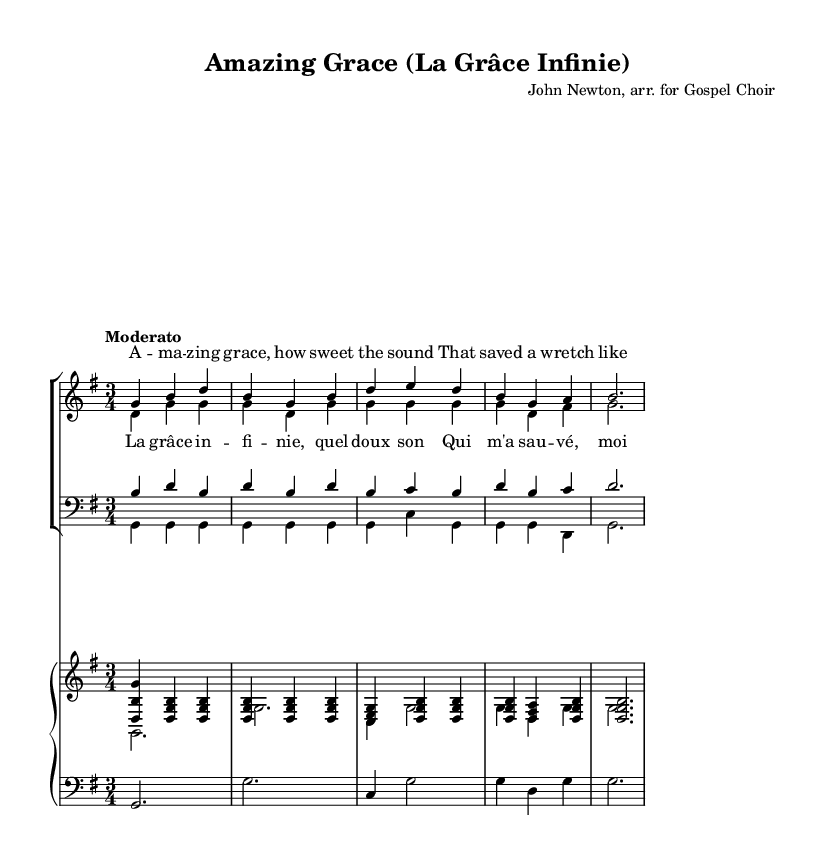What is the key signature of this music? The key signature is G major, which has one sharp (F#). You can determine the key signature by looking at the number of sharps or flats at the beginning of the staff. In this case, there is one sharp present.
Answer: G major What is the time signature of this piece? The time signature is 3/4, which indicates that there are three beats in each measure and the quarter note gets one beat. This can be seen at the beginning of the staff where the time signature is notated.
Answer: 3/4 What is the tempo marking for this arrangement? The tempo marking is "Moderato," indicating a moderate pace for the performance. This is usually written above the staff and provides guidance on the speed at which the piece should be played.
Answer: Moderato How many verses are included in the lyrics for this hymn? There is one verse included in the lyrics section of the sheet music. Although it is typical for hymns to have multiple verses, the provided sheet music shows only a single verse written underneath the soprano and alto parts.
Answer: One What is the primary emotion conveyed in the lyrics of this hymn? The primary emotion conveyed in the lyrics is grace, suggesting feelings of redemption and salvation. This can be inferred from the title and the lyrics that emphasize the sweetness and saving power of grace, which are common themes in Gospel music.
Answer: Grace How many staves are used for the vocal parts? There are two staves used for the vocal parts: one for women (soprano and alto) and one for men (tenor and bass). The layout clearly separates these two groups to allow for harmony and coordination between the vocal ranges.
Answer: Two What is the structure of the arrangement as indicated in the score? The structure includes a verse followed by a chorus, which is typical in Gospel arrangements for engaging congregation participation. The lyrics indicate a clear division between the verse and the chorus, enhancing the overall structure of the piece.
Answer: Verse and chorus 